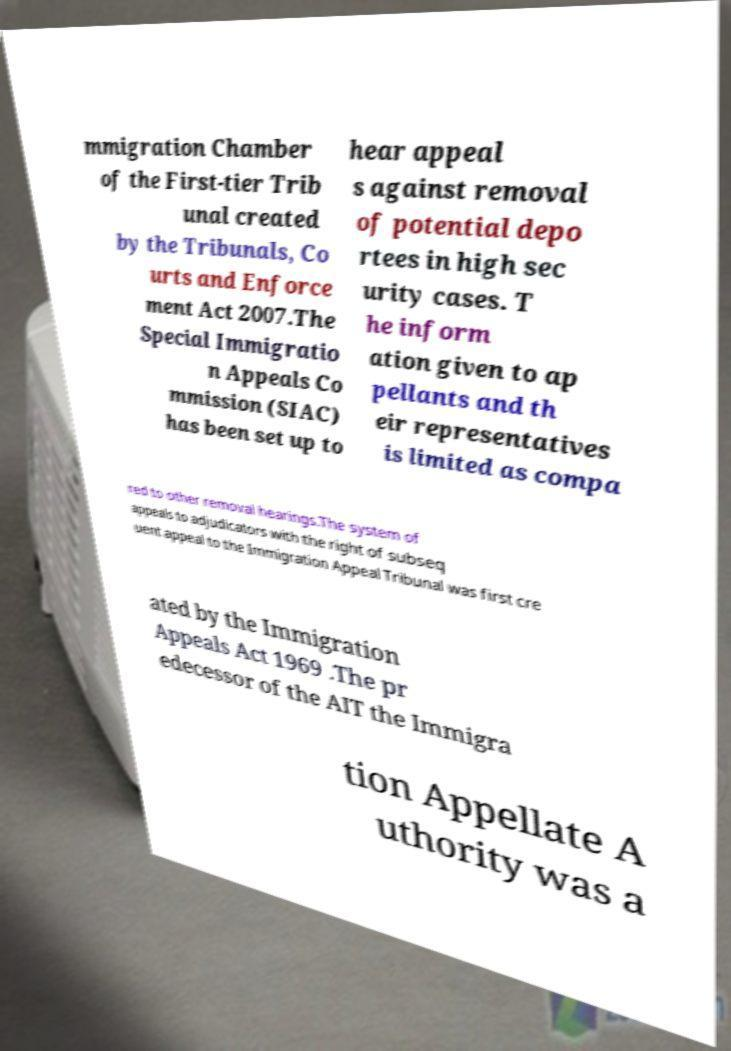I need the written content from this picture converted into text. Can you do that? mmigration Chamber of the First-tier Trib unal created by the Tribunals, Co urts and Enforce ment Act 2007.The Special Immigratio n Appeals Co mmission (SIAC) has been set up to hear appeal s against removal of potential depo rtees in high sec urity cases. T he inform ation given to ap pellants and th eir representatives is limited as compa red to other removal hearings.The system of appeals to adjudicators with the right of subseq uent appeal to the Immigration Appeal Tribunal was first cre ated by the Immigration Appeals Act 1969 .The pr edecessor of the AIT the Immigra tion Appellate A uthority was a 